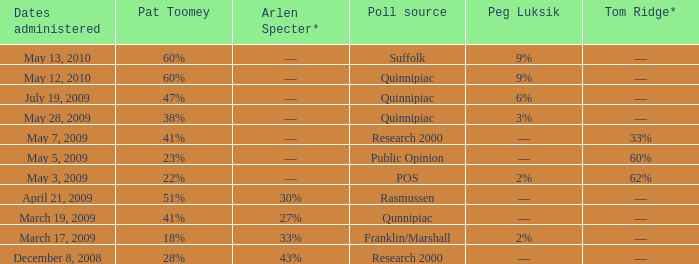Which Dates administered has an Arlen Specter* of ––, and a Peg Luksik of 9%? May 13, 2010, May 12, 2010. Can you give me this table as a dict? {'header': ['Dates administered', 'Pat Toomey', 'Arlen Specter*', 'Poll source', 'Peg Luksik', 'Tom Ridge*'], 'rows': [['May 13, 2010', '60%', '––', 'Suffolk', '9%', '––'], ['May 12, 2010', '60%', '––', 'Quinnipiac', '9%', '––'], ['July 19, 2009', '47%', '––', 'Quinnipiac', '6%', '––'], ['May 28, 2009', '38%', '––', 'Quinnipiac', '3%', '––'], ['May 7, 2009', '41%', '––', 'Research 2000', '––', '33%'], ['May 5, 2009', '23%', '––', 'Public Opinion', '––', '60%'], ['May 3, 2009', '22%', '––', 'POS', '2%', '62%'], ['April 21, 2009', '51%', '30%', 'Rasmussen', '––', '––'], ['March 19, 2009', '41%', '27%', 'Qunnipiac', '––', '––'], ['March 17, 2009', '18%', '33%', 'Franklin/Marshall', '2%', '––'], ['December 8, 2008', '28%', '43%', 'Research 2000', '––', '––']]} 